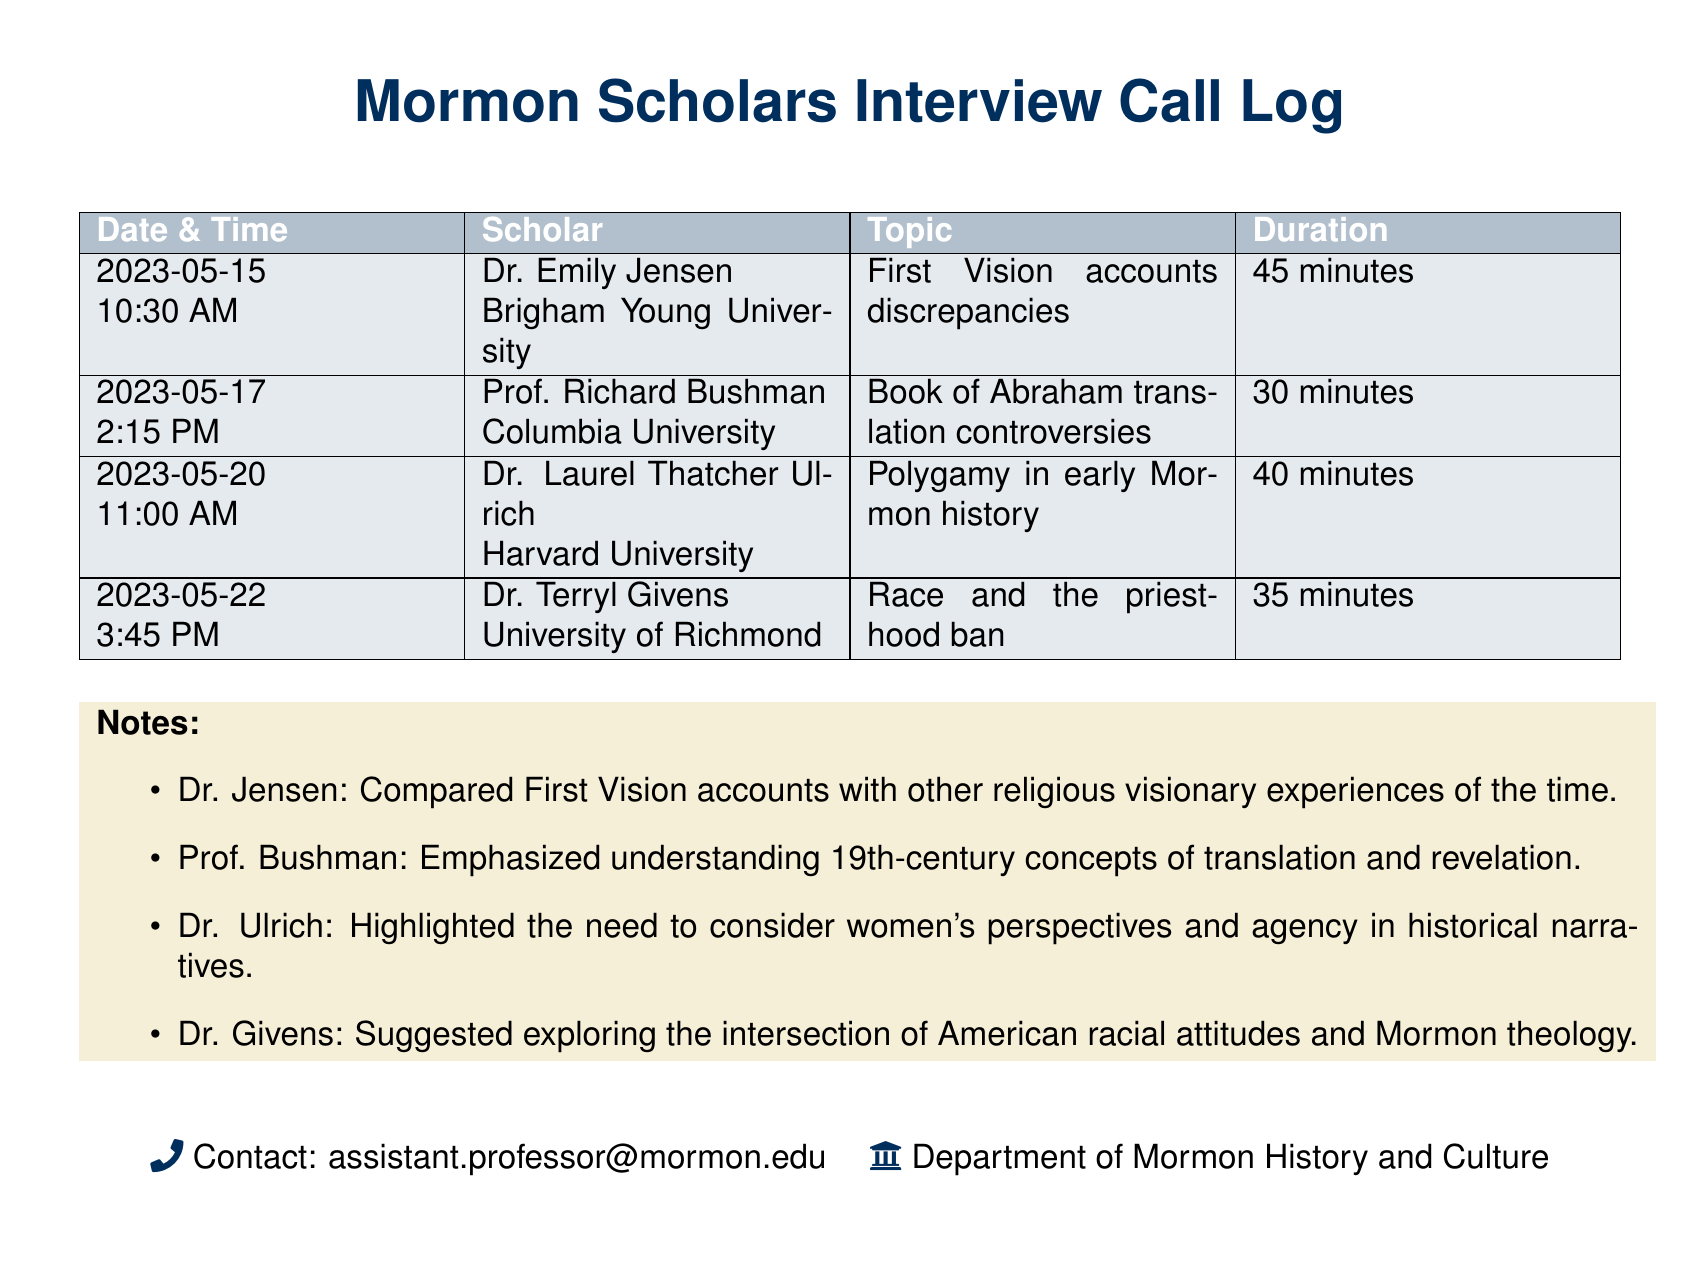What is the date of the interview with Dr. Emily Jensen? The document states that the interview with Dr. Emily Jensen took place on May 15, 2023.
Answer: May 15, 2023 How long did Prof. Richard Bushman's interview last? The duration of Prof. Richard Bushman's interview is listed as 30 minutes.
Answer: 30 minutes What topic did Dr. Laurel Thatcher Ulrich discuss during her interview? According to the document, Dr. Laurel Thatcher Ulrich's interview focused on polygamy in early Mormon history.
Answer: Polygamy in early Mormon history What is the total number of interviews logged in the document? By counting each entry, there are a total of four interviews recorded in the document.
Answer: 4 Which scholar emphasized women's perspectives in historical narratives? The document notes that Dr. Laurel Thatcher Ulrich highlighted the need to consider women's perspectives.
Answer: Dr. Laurel Thatcher Ulrich What was the topic of the interview with Dr. Terryl Givens? The document indicates that Dr. Terryl Givens discussed the race and the priesthood ban.
Answer: Race and the priesthood ban How many minutes long was the longest interview? The longest interview in the document is with Dr. Emily Jensen, lasting 45 minutes.
Answer: 45 minutes What color accents the document's title section? The title section of the document is accentuated with a specific color, which is identified as mormonblue.
Answer: mormonblue 